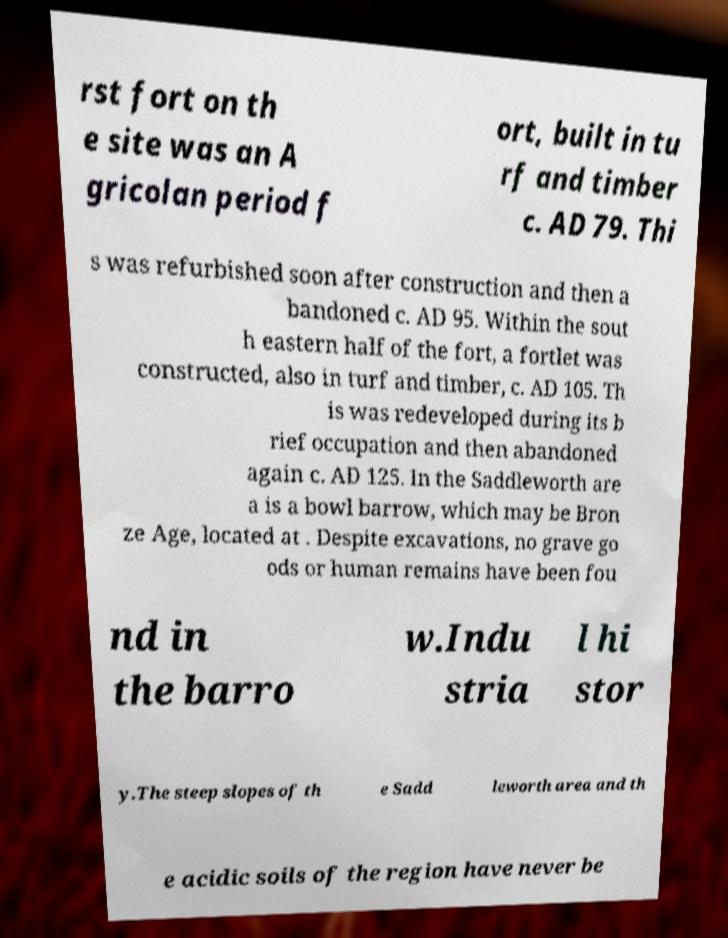I need the written content from this picture converted into text. Can you do that? rst fort on th e site was an A gricolan period f ort, built in tu rf and timber c. AD 79. Thi s was refurbished soon after construction and then a bandoned c. AD 95. Within the sout h eastern half of the fort, a fortlet was constructed, also in turf and timber, c. AD 105. Th is was redeveloped during its b rief occupation and then abandoned again c. AD 125. In the Saddleworth are a is a bowl barrow, which may be Bron ze Age, located at . Despite excavations, no grave go ods or human remains have been fou nd in the barro w.Indu stria l hi stor y.The steep slopes of th e Sadd leworth area and th e acidic soils of the region have never be 